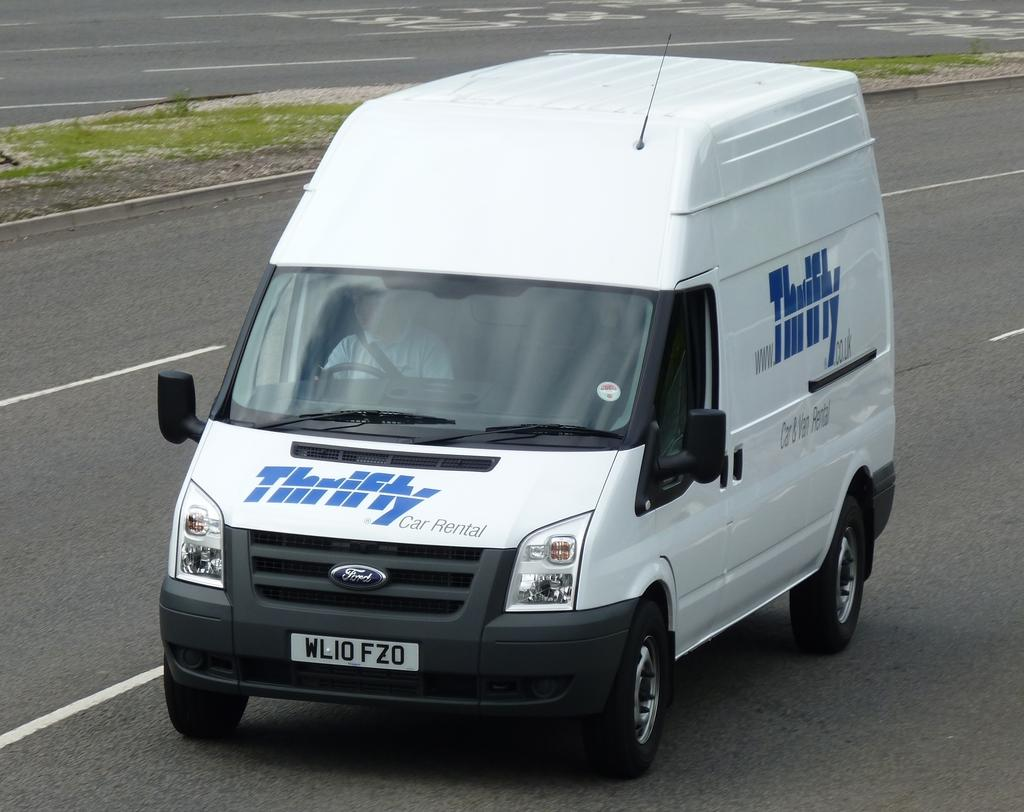<image>
Summarize the visual content of the image. White van which says the word Thrifty on it. 